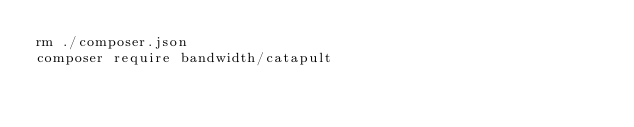<code> <loc_0><loc_0><loc_500><loc_500><_Bash_>rm ./composer.json
composer require bandwidth/catapult
</code> 